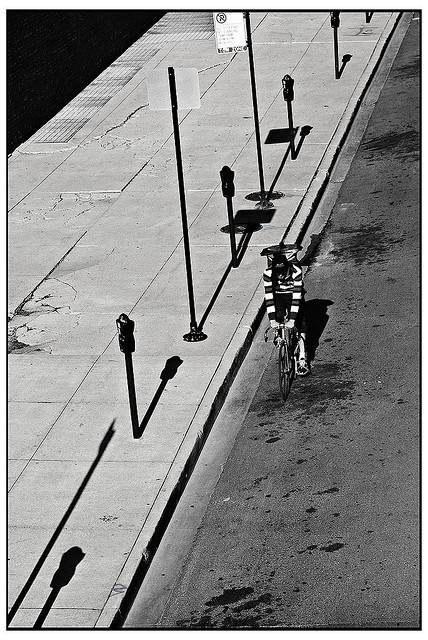Is this photo in black and white?
Give a very brief answer. Yes. What is on the man's shoulder?
Keep it brief. Backpack. What is the person riding?
Give a very brief answer. Bicycle. How many parking meters?
Write a very short answer. 4. 